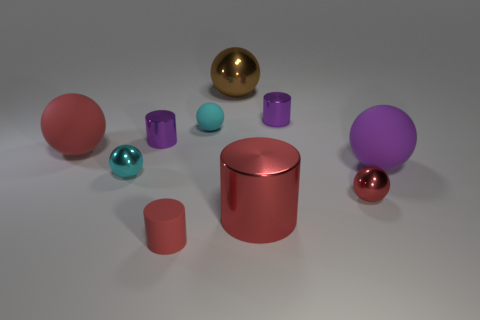Subtract 1 cylinders. How many cylinders are left? 3 Subtract all brown balls. How many balls are left? 5 Subtract all brown balls. How many balls are left? 5 Subtract all brown balls. Subtract all purple cylinders. How many balls are left? 5 Subtract all cylinders. How many objects are left? 6 Add 3 small matte things. How many small matte things exist? 5 Subtract 0 cyan cylinders. How many objects are left? 10 Subtract all red things. Subtract all large things. How many objects are left? 2 Add 7 tiny red metal balls. How many tiny red metal balls are left? 8 